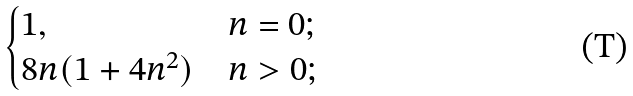<formula> <loc_0><loc_0><loc_500><loc_500>\begin{cases} 1 , & n = 0 ; \\ 8 n ( 1 + 4 n ^ { 2 } ) & n > 0 ; \\ \end{cases}</formula> 